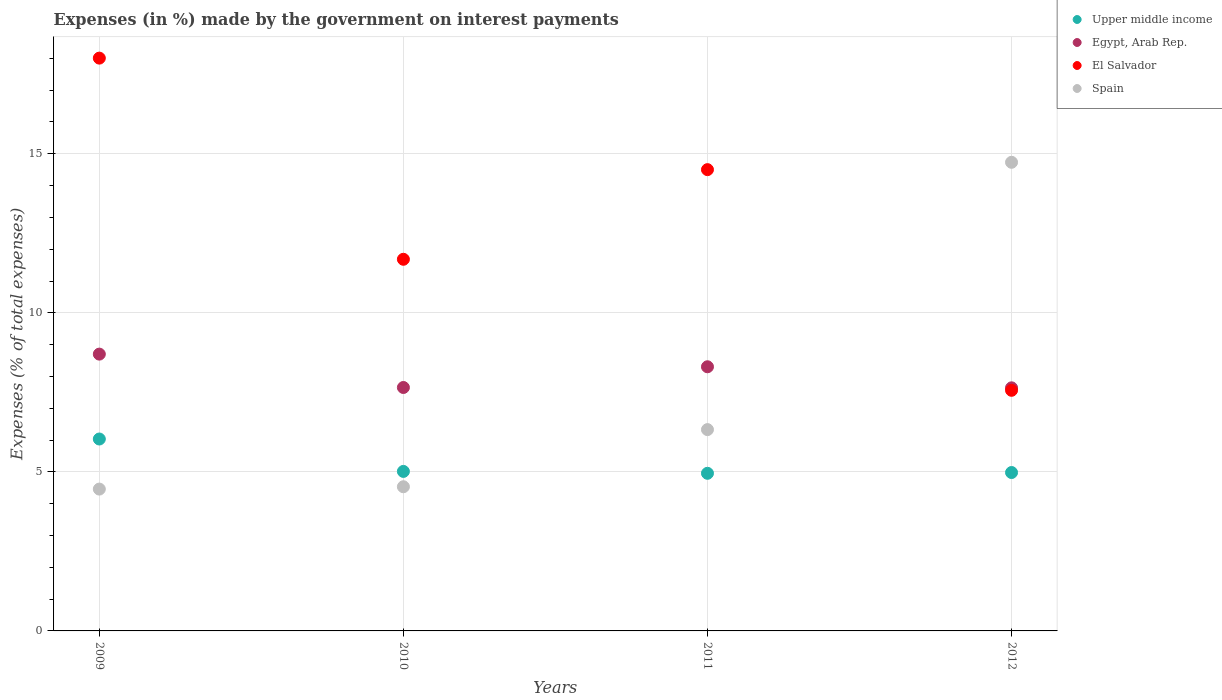How many different coloured dotlines are there?
Ensure brevity in your answer.  4. What is the percentage of expenses made by the government on interest payments in Egypt, Arab Rep. in 2010?
Ensure brevity in your answer.  7.65. Across all years, what is the maximum percentage of expenses made by the government on interest payments in El Salvador?
Provide a succinct answer. 18.01. Across all years, what is the minimum percentage of expenses made by the government on interest payments in Upper middle income?
Provide a succinct answer. 4.96. In which year was the percentage of expenses made by the government on interest payments in Spain maximum?
Offer a terse response. 2012. What is the total percentage of expenses made by the government on interest payments in Spain in the graph?
Keep it short and to the point. 30.05. What is the difference between the percentage of expenses made by the government on interest payments in El Salvador in 2010 and that in 2012?
Your response must be concise. 4.12. What is the difference between the percentage of expenses made by the government on interest payments in Spain in 2011 and the percentage of expenses made by the government on interest payments in Upper middle income in 2009?
Make the answer very short. 0.3. What is the average percentage of expenses made by the government on interest payments in Spain per year?
Provide a succinct answer. 7.51. In the year 2011, what is the difference between the percentage of expenses made by the government on interest payments in Spain and percentage of expenses made by the government on interest payments in Upper middle income?
Ensure brevity in your answer.  1.37. What is the ratio of the percentage of expenses made by the government on interest payments in Upper middle income in 2011 to that in 2012?
Give a very brief answer. 1. Is the percentage of expenses made by the government on interest payments in El Salvador in 2009 less than that in 2011?
Offer a terse response. No. What is the difference between the highest and the second highest percentage of expenses made by the government on interest payments in Egypt, Arab Rep.?
Provide a short and direct response. 0.4. What is the difference between the highest and the lowest percentage of expenses made by the government on interest payments in Upper middle income?
Make the answer very short. 1.08. In how many years, is the percentage of expenses made by the government on interest payments in Egypt, Arab Rep. greater than the average percentage of expenses made by the government on interest payments in Egypt, Arab Rep. taken over all years?
Your response must be concise. 2. Is the sum of the percentage of expenses made by the government on interest payments in Egypt, Arab Rep. in 2009 and 2012 greater than the maximum percentage of expenses made by the government on interest payments in El Salvador across all years?
Provide a short and direct response. No. Is it the case that in every year, the sum of the percentage of expenses made by the government on interest payments in Spain and percentage of expenses made by the government on interest payments in Upper middle income  is greater than the sum of percentage of expenses made by the government on interest payments in El Salvador and percentage of expenses made by the government on interest payments in Egypt, Arab Rep.?
Provide a short and direct response. No. Is it the case that in every year, the sum of the percentage of expenses made by the government on interest payments in Upper middle income and percentage of expenses made by the government on interest payments in Egypt, Arab Rep.  is greater than the percentage of expenses made by the government on interest payments in El Salvador?
Ensure brevity in your answer.  No. Does the percentage of expenses made by the government on interest payments in Upper middle income monotonically increase over the years?
Make the answer very short. No. Is the percentage of expenses made by the government on interest payments in Upper middle income strictly greater than the percentage of expenses made by the government on interest payments in Egypt, Arab Rep. over the years?
Provide a succinct answer. No. How many years are there in the graph?
Ensure brevity in your answer.  4. Are the values on the major ticks of Y-axis written in scientific E-notation?
Your answer should be very brief. No. Does the graph contain grids?
Give a very brief answer. Yes. Where does the legend appear in the graph?
Make the answer very short. Top right. How many legend labels are there?
Provide a succinct answer. 4. How are the legend labels stacked?
Give a very brief answer. Vertical. What is the title of the graph?
Make the answer very short. Expenses (in %) made by the government on interest payments. Does "Sint Maarten (Dutch part)" appear as one of the legend labels in the graph?
Your answer should be compact. No. What is the label or title of the X-axis?
Ensure brevity in your answer.  Years. What is the label or title of the Y-axis?
Keep it short and to the point. Expenses (% of total expenses). What is the Expenses (% of total expenses) of Upper middle income in 2009?
Keep it short and to the point. 6.03. What is the Expenses (% of total expenses) of Egypt, Arab Rep. in 2009?
Offer a terse response. 8.7. What is the Expenses (% of total expenses) in El Salvador in 2009?
Give a very brief answer. 18.01. What is the Expenses (% of total expenses) in Spain in 2009?
Your answer should be compact. 4.46. What is the Expenses (% of total expenses) in Upper middle income in 2010?
Ensure brevity in your answer.  5.01. What is the Expenses (% of total expenses) of Egypt, Arab Rep. in 2010?
Offer a terse response. 7.65. What is the Expenses (% of total expenses) of El Salvador in 2010?
Provide a succinct answer. 11.68. What is the Expenses (% of total expenses) of Spain in 2010?
Provide a succinct answer. 4.53. What is the Expenses (% of total expenses) in Upper middle income in 2011?
Your answer should be very brief. 4.96. What is the Expenses (% of total expenses) of Egypt, Arab Rep. in 2011?
Provide a short and direct response. 8.3. What is the Expenses (% of total expenses) in El Salvador in 2011?
Give a very brief answer. 14.5. What is the Expenses (% of total expenses) of Spain in 2011?
Your answer should be compact. 6.33. What is the Expenses (% of total expenses) in Upper middle income in 2012?
Your answer should be compact. 4.98. What is the Expenses (% of total expenses) of Egypt, Arab Rep. in 2012?
Offer a terse response. 7.64. What is the Expenses (% of total expenses) of El Salvador in 2012?
Give a very brief answer. 7.56. What is the Expenses (% of total expenses) of Spain in 2012?
Ensure brevity in your answer.  14.73. Across all years, what is the maximum Expenses (% of total expenses) in Upper middle income?
Offer a terse response. 6.03. Across all years, what is the maximum Expenses (% of total expenses) in Egypt, Arab Rep.?
Offer a terse response. 8.7. Across all years, what is the maximum Expenses (% of total expenses) in El Salvador?
Provide a short and direct response. 18.01. Across all years, what is the maximum Expenses (% of total expenses) in Spain?
Keep it short and to the point. 14.73. Across all years, what is the minimum Expenses (% of total expenses) in Upper middle income?
Offer a terse response. 4.96. Across all years, what is the minimum Expenses (% of total expenses) of Egypt, Arab Rep.?
Your response must be concise. 7.64. Across all years, what is the minimum Expenses (% of total expenses) of El Salvador?
Provide a succinct answer. 7.56. Across all years, what is the minimum Expenses (% of total expenses) of Spain?
Your answer should be compact. 4.46. What is the total Expenses (% of total expenses) in Upper middle income in the graph?
Provide a short and direct response. 20.98. What is the total Expenses (% of total expenses) of Egypt, Arab Rep. in the graph?
Provide a succinct answer. 32.3. What is the total Expenses (% of total expenses) in El Salvador in the graph?
Ensure brevity in your answer.  51.75. What is the total Expenses (% of total expenses) in Spain in the graph?
Your answer should be compact. 30.05. What is the difference between the Expenses (% of total expenses) in Upper middle income in 2009 and that in 2010?
Make the answer very short. 1.02. What is the difference between the Expenses (% of total expenses) in Egypt, Arab Rep. in 2009 and that in 2010?
Keep it short and to the point. 1.05. What is the difference between the Expenses (% of total expenses) in El Salvador in 2009 and that in 2010?
Make the answer very short. 6.32. What is the difference between the Expenses (% of total expenses) in Spain in 2009 and that in 2010?
Ensure brevity in your answer.  -0.07. What is the difference between the Expenses (% of total expenses) of Upper middle income in 2009 and that in 2011?
Your answer should be compact. 1.08. What is the difference between the Expenses (% of total expenses) in Egypt, Arab Rep. in 2009 and that in 2011?
Offer a very short reply. 0.4. What is the difference between the Expenses (% of total expenses) in El Salvador in 2009 and that in 2011?
Provide a short and direct response. 3.51. What is the difference between the Expenses (% of total expenses) of Spain in 2009 and that in 2011?
Your response must be concise. -1.87. What is the difference between the Expenses (% of total expenses) of Upper middle income in 2009 and that in 2012?
Keep it short and to the point. 1.05. What is the difference between the Expenses (% of total expenses) in Egypt, Arab Rep. in 2009 and that in 2012?
Your answer should be very brief. 1.06. What is the difference between the Expenses (% of total expenses) in El Salvador in 2009 and that in 2012?
Your answer should be very brief. 10.44. What is the difference between the Expenses (% of total expenses) in Spain in 2009 and that in 2012?
Ensure brevity in your answer.  -10.27. What is the difference between the Expenses (% of total expenses) in Upper middle income in 2010 and that in 2011?
Provide a succinct answer. 0.06. What is the difference between the Expenses (% of total expenses) of Egypt, Arab Rep. in 2010 and that in 2011?
Keep it short and to the point. -0.65. What is the difference between the Expenses (% of total expenses) in El Salvador in 2010 and that in 2011?
Provide a short and direct response. -2.82. What is the difference between the Expenses (% of total expenses) in Spain in 2010 and that in 2011?
Provide a succinct answer. -1.8. What is the difference between the Expenses (% of total expenses) of Upper middle income in 2010 and that in 2012?
Your response must be concise. 0.03. What is the difference between the Expenses (% of total expenses) of Egypt, Arab Rep. in 2010 and that in 2012?
Offer a terse response. 0.01. What is the difference between the Expenses (% of total expenses) in El Salvador in 2010 and that in 2012?
Make the answer very short. 4.12. What is the difference between the Expenses (% of total expenses) of Spain in 2010 and that in 2012?
Provide a succinct answer. -10.2. What is the difference between the Expenses (% of total expenses) of Upper middle income in 2011 and that in 2012?
Provide a short and direct response. -0.02. What is the difference between the Expenses (% of total expenses) of Egypt, Arab Rep. in 2011 and that in 2012?
Your response must be concise. 0.66. What is the difference between the Expenses (% of total expenses) in El Salvador in 2011 and that in 2012?
Provide a short and direct response. 6.94. What is the difference between the Expenses (% of total expenses) of Spain in 2011 and that in 2012?
Your response must be concise. -8.4. What is the difference between the Expenses (% of total expenses) of Upper middle income in 2009 and the Expenses (% of total expenses) of Egypt, Arab Rep. in 2010?
Your response must be concise. -1.62. What is the difference between the Expenses (% of total expenses) in Upper middle income in 2009 and the Expenses (% of total expenses) in El Salvador in 2010?
Your answer should be compact. -5.65. What is the difference between the Expenses (% of total expenses) in Upper middle income in 2009 and the Expenses (% of total expenses) in Spain in 2010?
Provide a succinct answer. 1.5. What is the difference between the Expenses (% of total expenses) in Egypt, Arab Rep. in 2009 and the Expenses (% of total expenses) in El Salvador in 2010?
Give a very brief answer. -2.98. What is the difference between the Expenses (% of total expenses) of Egypt, Arab Rep. in 2009 and the Expenses (% of total expenses) of Spain in 2010?
Offer a terse response. 4.17. What is the difference between the Expenses (% of total expenses) in El Salvador in 2009 and the Expenses (% of total expenses) in Spain in 2010?
Make the answer very short. 13.47. What is the difference between the Expenses (% of total expenses) in Upper middle income in 2009 and the Expenses (% of total expenses) in Egypt, Arab Rep. in 2011?
Make the answer very short. -2.27. What is the difference between the Expenses (% of total expenses) in Upper middle income in 2009 and the Expenses (% of total expenses) in El Salvador in 2011?
Provide a succinct answer. -8.47. What is the difference between the Expenses (% of total expenses) in Upper middle income in 2009 and the Expenses (% of total expenses) in Spain in 2011?
Keep it short and to the point. -0.3. What is the difference between the Expenses (% of total expenses) of Egypt, Arab Rep. in 2009 and the Expenses (% of total expenses) of El Salvador in 2011?
Provide a short and direct response. -5.8. What is the difference between the Expenses (% of total expenses) in Egypt, Arab Rep. in 2009 and the Expenses (% of total expenses) in Spain in 2011?
Offer a very short reply. 2.37. What is the difference between the Expenses (% of total expenses) in El Salvador in 2009 and the Expenses (% of total expenses) in Spain in 2011?
Ensure brevity in your answer.  11.68. What is the difference between the Expenses (% of total expenses) in Upper middle income in 2009 and the Expenses (% of total expenses) in Egypt, Arab Rep. in 2012?
Your answer should be compact. -1.61. What is the difference between the Expenses (% of total expenses) in Upper middle income in 2009 and the Expenses (% of total expenses) in El Salvador in 2012?
Provide a short and direct response. -1.53. What is the difference between the Expenses (% of total expenses) in Upper middle income in 2009 and the Expenses (% of total expenses) in Spain in 2012?
Your response must be concise. -8.7. What is the difference between the Expenses (% of total expenses) of Egypt, Arab Rep. in 2009 and the Expenses (% of total expenses) of El Salvador in 2012?
Provide a short and direct response. 1.14. What is the difference between the Expenses (% of total expenses) of Egypt, Arab Rep. in 2009 and the Expenses (% of total expenses) of Spain in 2012?
Keep it short and to the point. -6.03. What is the difference between the Expenses (% of total expenses) of El Salvador in 2009 and the Expenses (% of total expenses) of Spain in 2012?
Provide a short and direct response. 3.27. What is the difference between the Expenses (% of total expenses) of Upper middle income in 2010 and the Expenses (% of total expenses) of Egypt, Arab Rep. in 2011?
Your answer should be compact. -3.29. What is the difference between the Expenses (% of total expenses) of Upper middle income in 2010 and the Expenses (% of total expenses) of El Salvador in 2011?
Your response must be concise. -9.49. What is the difference between the Expenses (% of total expenses) in Upper middle income in 2010 and the Expenses (% of total expenses) in Spain in 2011?
Keep it short and to the point. -1.31. What is the difference between the Expenses (% of total expenses) of Egypt, Arab Rep. in 2010 and the Expenses (% of total expenses) of El Salvador in 2011?
Your answer should be compact. -6.85. What is the difference between the Expenses (% of total expenses) of Egypt, Arab Rep. in 2010 and the Expenses (% of total expenses) of Spain in 2011?
Your answer should be very brief. 1.32. What is the difference between the Expenses (% of total expenses) of El Salvador in 2010 and the Expenses (% of total expenses) of Spain in 2011?
Ensure brevity in your answer.  5.35. What is the difference between the Expenses (% of total expenses) of Upper middle income in 2010 and the Expenses (% of total expenses) of Egypt, Arab Rep. in 2012?
Make the answer very short. -2.63. What is the difference between the Expenses (% of total expenses) in Upper middle income in 2010 and the Expenses (% of total expenses) in El Salvador in 2012?
Your answer should be compact. -2.55. What is the difference between the Expenses (% of total expenses) in Upper middle income in 2010 and the Expenses (% of total expenses) in Spain in 2012?
Provide a succinct answer. -9.72. What is the difference between the Expenses (% of total expenses) of Egypt, Arab Rep. in 2010 and the Expenses (% of total expenses) of El Salvador in 2012?
Offer a terse response. 0.09. What is the difference between the Expenses (% of total expenses) in Egypt, Arab Rep. in 2010 and the Expenses (% of total expenses) in Spain in 2012?
Offer a very short reply. -7.08. What is the difference between the Expenses (% of total expenses) of El Salvador in 2010 and the Expenses (% of total expenses) of Spain in 2012?
Provide a succinct answer. -3.05. What is the difference between the Expenses (% of total expenses) in Upper middle income in 2011 and the Expenses (% of total expenses) in Egypt, Arab Rep. in 2012?
Your answer should be compact. -2.69. What is the difference between the Expenses (% of total expenses) of Upper middle income in 2011 and the Expenses (% of total expenses) of El Salvador in 2012?
Offer a very short reply. -2.61. What is the difference between the Expenses (% of total expenses) of Upper middle income in 2011 and the Expenses (% of total expenses) of Spain in 2012?
Give a very brief answer. -9.78. What is the difference between the Expenses (% of total expenses) of Egypt, Arab Rep. in 2011 and the Expenses (% of total expenses) of El Salvador in 2012?
Give a very brief answer. 0.74. What is the difference between the Expenses (% of total expenses) in Egypt, Arab Rep. in 2011 and the Expenses (% of total expenses) in Spain in 2012?
Your response must be concise. -6.43. What is the difference between the Expenses (% of total expenses) of El Salvador in 2011 and the Expenses (% of total expenses) of Spain in 2012?
Make the answer very short. -0.23. What is the average Expenses (% of total expenses) of Upper middle income per year?
Offer a terse response. 5.25. What is the average Expenses (% of total expenses) in Egypt, Arab Rep. per year?
Give a very brief answer. 8.07. What is the average Expenses (% of total expenses) in El Salvador per year?
Your response must be concise. 12.94. What is the average Expenses (% of total expenses) in Spain per year?
Your answer should be compact. 7.51. In the year 2009, what is the difference between the Expenses (% of total expenses) of Upper middle income and Expenses (% of total expenses) of Egypt, Arab Rep.?
Keep it short and to the point. -2.67. In the year 2009, what is the difference between the Expenses (% of total expenses) in Upper middle income and Expenses (% of total expenses) in El Salvador?
Give a very brief answer. -11.97. In the year 2009, what is the difference between the Expenses (% of total expenses) in Upper middle income and Expenses (% of total expenses) in Spain?
Give a very brief answer. 1.57. In the year 2009, what is the difference between the Expenses (% of total expenses) of Egypt, Arab Rep. and Expenses (% of total expenses) of El Salvador?
Provide a succinct answer. -9.3. In the year 2009, what is the difference between the Expenses (% of total expenses) of Egypt, Arab Rep. and Expenses (% of total expenses) of Spain?
Your answer should be very brief. 4.24. In the year 2009, what is the difference between the Expenses (% of total expenses) in El Salvador and Expenses (% of total expenses) in Spain?
Offer a very short reply. 13.55. In the year 2010, what is the difference between the Expenses (% of total expenses) in Upper middle income and Expenses (% of total expenses) in Egypt, Arab Rep.?
Offer a terse response. -2.64. In the year 2010, what is the difference between the Expenses (% of total expenses) in Upper middle income and Expenses (% of total expenses) in El Salvador?
Your answer should be very brief. -6.67. In the year 2010, what is the difference between the Expenses (% of total expenses) in Upper middle income and Expenses (% of total expenses) in Spain?
Make the answer very short. 0.48. In the year 2010, what is the difference between the Expenses (% of total expenses) in Egypt, Arab Rep. and Expenses (% of total expenses) in El Salvador?
Ensure brevity in your answer.  -4.03. In the year 2010, what is the difference between the Expenses (% of total expenses) in Egypt, Arab Rep. and Expenses (% of total expenses) in Spain?
Ensure brevity in your answer.  3.12. In the year 2010, what is the difference between the Expenses (% of total expenses) of El Salvador and Expenses (% of total expenses) of Spain?
Provide a succinct answer. 7.15. In the year 2011, what is the difference between the Expenses (% of total expenses) of Upper middle income and Expenses (% of total expenses) of Egypt, Arab Rep.?
Your response must be concise. -3.35. In the year 2011, what is the difference between the Expenses (% of total expenses) in Upper middle income and Expenses (% of total expenses) in El Salvador?
Your answer should be compact. -9.55. In the year 2011, what is the difference between the Expenses (% of total expenses) of Upper middle income and Expenses (% of total expenses) of Spain?
Keep it short and to the point. -1.37. In the year 2011, what is the difference between the Expenses (% of total expenses) of Egypt, Arab Rep. and Expenses (% of total expenses) of El Salvador?
Your answer should be compact. -6.2. In the year 2011, what is the difference between the Expenses (% of total expenses) of Egypt, Arab Rep. and Expenses (% of total expenses) of Spain?
Give a very brief answer. 1.98. In the year 2011, what is the difference between the Expenses (% of total expenses) in El Salvador and Expenses (% of total expenses) in Spain?
Your answer should be compact. 8.17. In the year 2012, what is the difference between the Expenses (% of total expenses) of Upper middle income and Expenses (% of total expenses) of Egypt, Arab Rep.?
Give a very brief answer. -2.66. In the year 2012, what is the difference between the Expenses (% of total expenses) in Upper middle income and Expenses (% of total expenses) in El Salvador?
Your response must be concise. -2.58. In the year 2012, what is the difference between the Expenses (% of total expenses) of Upper middle income and Expenses (% of total expenses) of Spain?
Make the answer very short. -9.75. In the year 2012, what is the difference between the Expenses (% of total expenses) in Egypt, Arab Rep. and Expenses (% of total expenses) in El Salvador?
Your answer should be compact. 0.08. In the year 2012, what is the difference between the Expenses (% of total expenses) of Egypt, Arab Rep. and Expenses (% of total expenses) of Spain?
Make the answer very short. -7.09. In the year 2012, what is the difference between the Expenses (% of total expenses) in El Salvador and Expenses (% of total expenses) in Spain?
Keep it short and to the point. -7.17. What is the ratio of the Expenses (% of total expenses) in Upper middle income in 2009 to that in 2010?
Your answer should be very brief. 1.2. What is the ratio of the Expenses (% of total expenses) of Egypt, Arab Rep. in 2009 to that in 2010?
Your answer should be compact. 1.14. What is the ratio of the Expenses (% of total expenses) of El Salvador in 2009 to that in 2010?
Give a very brief answer. 1.54. What is the ratio of the Expenses (% of total expenses) of Spain in 2009 to that in 2010?
Provide a short and direct response. 0.98. What is the ratio of the Expenses (% of total expenses) in Upper middle income in 2009 to that in 2011?
Offer a very short reply. 1.22. What is the ratio of the Expenses (% of total expenses) in Egypt, Arab Rep. in 2009 to that in 2011?
Offer a terse response. 1.05. What is the ratio of the Expenses (% of total expenses) of El Salvador in 2009 to that in 2011?
Make the answer very short. 1.24. What is the ratio of the Expenses (% of total expenses) of Spain in 2009 to that in 2011?
Provide a short and direct response. 0.7. What is the ratio of the Expenses (% of total expenses) of Upper middle income in 2009 to that in 2012?
Your response must be concise. 1.21. What is the ratio of the Expenses (% of total expenses) of Egypt, Arab Rep. in 2009 to that in 2012?
Offer a very short reply. 1.14. What is the ratio of the Expenses (% of total expenses) in El Salvador in 2009 to that in 2012?
Offer a very short reply. 2.38. What is the ratio of the Expenses (% of total expenses) in Spain in 2009 to that in 2012?
Your answer should be compact. 0.3. What is the ratio of the Expenses (% of total expenses) in Upper middle income in 2010 to that in 2011?
Give a very brief answer. 1.01. What is the ratio of the Expenses (% of total expenses) of Egypt, Arab Rep. in 2010 to that in 2011?
Provide a short and direct response. 0.92. What is the ratio of the Expenses (% of total expenses) of El Salvador in 2010 to that in 2011?
Your response must be concise. 0.81. What is the ratio of the Expenses (% of total expenses) in Spain in 2010 to that in 2011?
Provide a succinct answer. 0.72. What is the ratio of the Expenses (% of total expenses) in Upper middle income in 2010 to that in 2012?
Your answer should be very brief. 1.01. What is the ratio of the Expenses (% of total expenses) in El Salvador in 2010 to that in 2012?
Make the answer very short. 1.54. What is the ratio of the Expenses (% of total expenses) in Spain in 2010 to that in 2012?
Your answer should be very brief. 0.31. What is the ratio of the Expenses (% of total expenses) of Egypt, Arab Rep. in 2011 to that in 2012?
Your response must be concise. 1.09. What is the ratio of the Expenses (% of total expenses) in El Salvador in 2011 to that in 2012?
Ensure brevity in your answer.  1.92. What is the ratio of the Expenses (% of total expenses) in Spain in 2011 to that in 2012?
Offer a very short reply. 0.43. What is the difference between the highest and the second highest Expenses (% of total expenses) of Upper middle income?
Give a very brief answer. 1.02. What is the difference between the highest and the second highest Expenses (% of total expenses) of Egypt, Arab Rep.?
Give a very brief answer. 0.4. What is the difference between the highest and the second highest Expenses (% of total expenses) of El Salvador?
Your response must be concise. 3.51. What is the difference between the highest and the second highest Expenses (% of total expenses) of Spain?
Provide a succinct answer. 8.4. What is the difference between the highest and the lowest Expenses (% of total expenses) in Upper middle income?
Offer a terse response. 1.08. What is the difference between the highest and the lowest Expenses (% of total expenses) in Egypt, Arab Rep.?
Make the answer very short. 1.06. What is the difference between the highest and the lowest Expenses (% of total expenses) of El Salvador?
Provide a succinct answer. 10.44. What is the difference between the highest and the lowest Expenses (% of total expenses) in Spain?
Offer a very short reply. 10.27. 